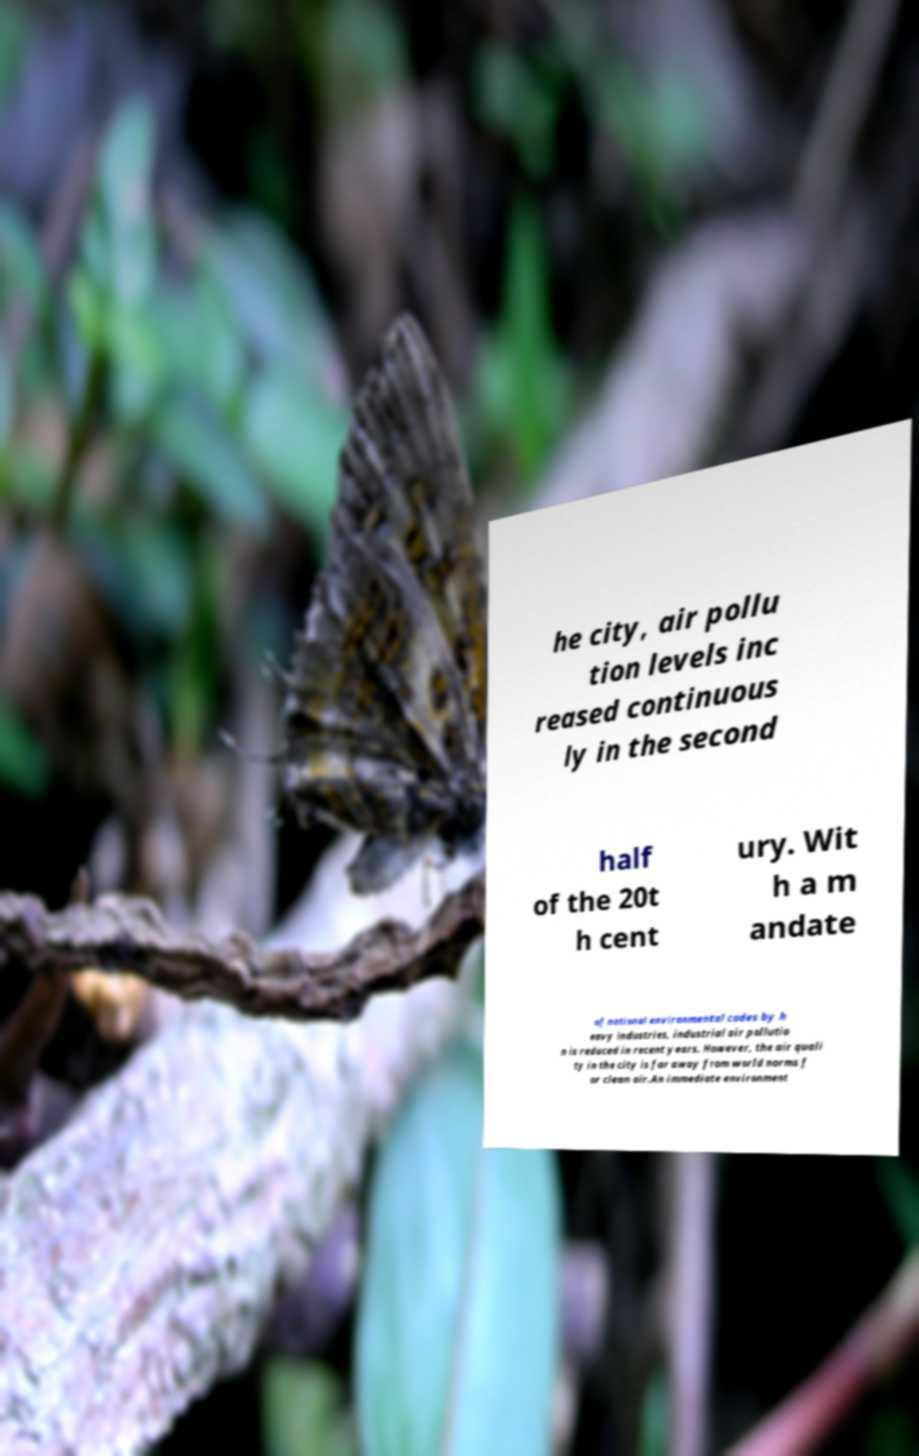For documentation purposes, I need the text within this image transcribed. Could you provide that? he city, air pollu tion levels inc reased continuous ly in the second half of the 20t h cent ury. Wit h a m andate of national environmental codes by h eavy industries, industrial air pollutio n is reduced in recent years. However, the air quali ty in the city is far away from world norms f or clean air.An immediate environment 